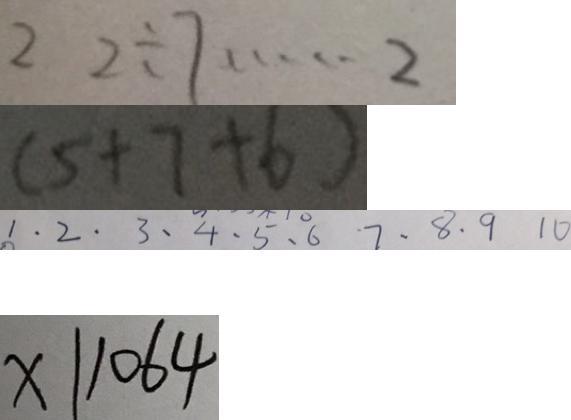<formula> <loc_0><loc_0><loc_500><loc_500>2 2 \div 7 \cdots 2 
 ( 5 + 7 + 6 ) 
 1 . 2 . 3 . 4 . 5 . 6 7 . 8 . 9 1 0 
 x \vert 1 0 6 4</formula> 